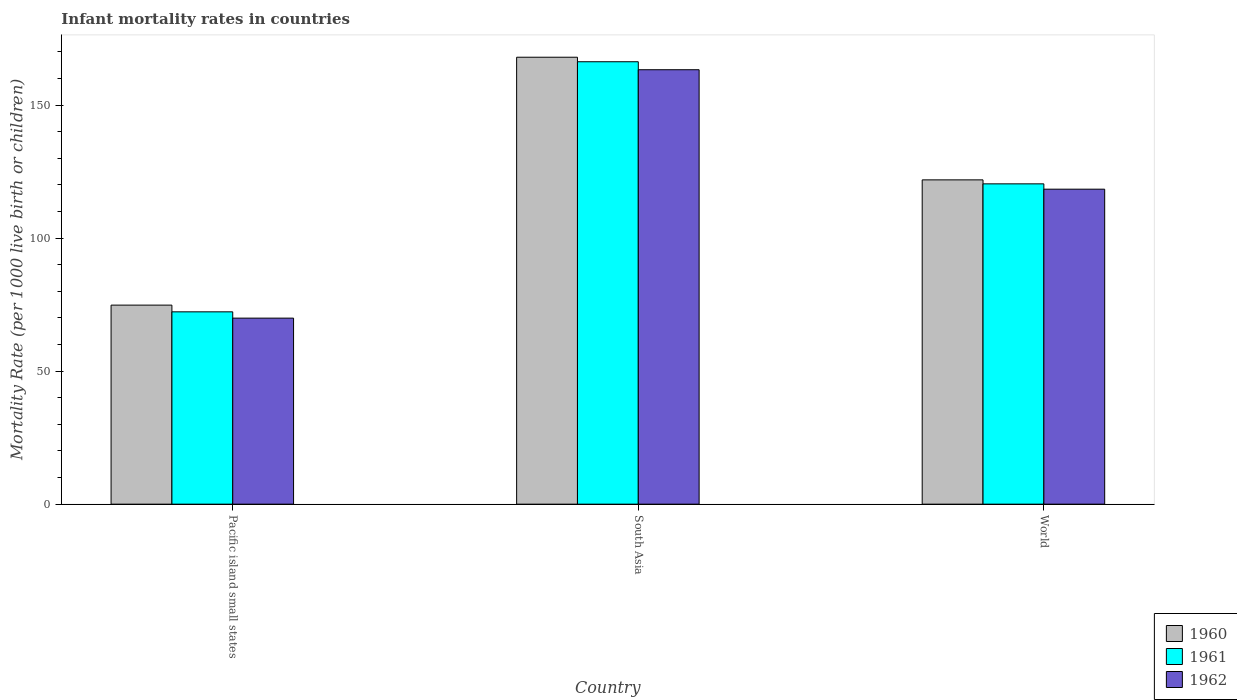Are the number of bars on each tick of the X-axis equal?
Make the answer very short. Yes. What is the label of the 2nd group of bars from the left?
Offer a very short reply. South Asia. In how many cases, is the number of bars for a given country not equal to the number of legend labels?
Your answer should be compact. 0. What is the infant mortality rate in 1961 in Pacific island small states?
Provide a short and direct response. 72.29. Across all countries, what is the maximum infant mortality rate in 1961?
Give a very brief answer. 166.3. Across all countries, what is the minimum infant mortality rate in 1961?
Offer a terse response. 72.29. In which country was the infant mortality rate in 1961 minimum?
Offer a terse response. Pacific island small states. What is the total infant mortality rate in 1961 in the graph?
Your answer should be compact. 358.99. What is the difference between the infant mortality rate in 1960 in Pacific island small states and that in World?
Provide a short and direct response. -47.08. What is the difference between the infant mortality rate in 1962 in Pacific island small states and the infant mortality rate in 1960 in South Asia?
Provide a short and direct response. -98.07. What is the average infant mortality rate in 1962 per country?
Keep it short and to the point. 117.21. What is the difference between the infant mortality rate of/in 1960 and infant mortality rate of/in 1962 in South Asia?
Offer a terse response. 4.7. What is the ratio of the infant mortality rate in 1960 in Pacific island small states to that in World?
Give a very brief answer. 0.61. What is the difference between the highest and the second highest infant mortality rate in 1961?
Your response must be concise. 48.11. What is the difference between the highest and the lowest infant mortality rate in 1962?
Offer a terse response. 93.37. In how many countries, is the infant mortality rate in 1961 greater than the average infant mortality rate in 1961 taken over all countries?
Your answer should be very brief. 2. What does the 1st bar from the left in Pacific island small states represents?
Offer a very short reply. 1960. What does the 3rd bar from the right in World represents?
Give a very brief answer. 1960. Are all the bars in the graph horizontal?
Provide a succinct answer. No. Are the values on the major ticks of Y-axis written in scientific E-notation?
Your response must be concise. No. Does the graph contain grids?
Offer a terse response. No. Where does the legend appear in the graph?
Offer a terse response. Bottom right. How many legend labels are there?
Provide a short and direct response. 3. How are the legend labels stacked?
Make the answer very short. Vertical. What is the title of the graph?
Offer a very short reply. Infant mortality rates in countries. What is the label or title of the Y-axis?
Give a very brief answer. Mortality Rate (per 1000 live birth or children). What is the Mortality Rate (per 1000 live birth or children) in 1960 in Pacific island small states?
Offer a very short reply. 74.82. What is the Mortality Rate (per 1000 live birth or children) of 1961 in Pacific island small states?
Give a very brief answer. 72.29. What is the Mortality Rate (per 1000 live birth or children) of 1962 in Pacific island small states?
Your answer should be very brief. 69.93. What is the Mortality Rate (per 1000 live birth or children) in 1960 in South Asia?
Give a very brief answer. 168. What is the Mortality Rate (per 1000 live birth or children) of 1961 in South Asia?
Offer a terse response. 166.3. What is the Mortality Rate (per 1000 live birth or children) in 1962 in South Asia?
Your response must be concise. 163.3. What is the Mortality Rate (per 1000 live birth or children) in 1960 in World?
Provide a succinct answer. 121.9. What is the Mortality Rate (per 1000 live birth or children) in 1961 in World?
Make the answer very short. 120.4. What is the Mortality Rate (per 1000 live birth or children) of 1962 in World?
Your answer should be very brief. 118.4. Across all countries, what is the maximum Mortality Rate (per 1000 live birth or children) in 1960?
Provide a succinct answer. 168. Across all countries, what is the maximum Mortality Rate (per 1000 live birth or children) of 1961?
Your answer should be compact. 166.3. Across all countries, what is the maximum Mortality Rate (per 1000 live birth or children) of 1962?
Your response must be concise. 163.3. Across all countries, what is the minimum Mortality Rate (per 1000 live birth or children) of 1960?
Make the answer very short. 74.82. Across all countries, what is the minimum Mortality Rate (per 1000 live birth or children) in 1961?
Provide a short and direct response. 72.29. Across all countries, what is the minimum Mortality Rate (per 1000 live birth or children) of 1962?
Ensure brevity in your answer.  69.93. What is the total Mortality Rate (per 1000 live birth or children) in 1960 in the graph?
Offer a terse response. 364.72. What is the total Mortality Rate (per 1000 live birth or children) of 1961 in the graph?
Offer a very short reply. 358.99. What is the total Mortality Rate (per 1000 live birth or children) in 1962 in the graph?
Provide a succinct answer. 351.63. What is the difference between the Mortality Rate (per 1000 live birth or children) in 1960 in Pacific island small states and that in South Asia?
Make the answer very short. -93.18. What is the difference between the Mortality Rate (per 1000 live birth or children) of 1961 in Pacific island small states and that in South Asia?
Keep it short and to the point. -94.01. What is the difference between the Mortality Rate (per 1000 live birth or children) in 1962 in Pacific island small states and that in South Asia?
Keep it short and to the point. -93.37. What is the difference between the Mortality Rate (per 1000 live birth or children) of 1960 in Pacific island small states and that in World?
Ensure brevity in your answer.  -47.08. What is the difference between the Mortality Rate (per 1000 live birth or children) of 1961 in Pacific island small states and that in World?
Provide a short and direct response. -48.11. What is the difference between the Mortality Rate (per 1000 live birth or children) of 1962 in Pacific island small states and that in World?
Your answer should be very brief. -48.47. What is the difference between the Mortality Rate (per 1000 live birth or children) in 1960 in South Asia and that in World?
Provide a succinct answer. 46.1. What is the difference between the Mortality Rate (per 1000 live birth or children) of 1961 in South Asia and that in World?
Offer a very short reply. 45.9. What is the difference between the Mortality Rate (per 1000 live birth or children) in 1962 in South Asia and that in World?
Provide a short and direct response. 44.9. What is the difference between the Mortality Rate (per 1000 live birth or children) in 1960 in Pacific island small states and the Mortality Rate (per 1000 live birth or children) in 1961 in South Asia?
Provide a succinct answer. -91.48. What is the difference between the Mortality Rate (per 1000 live birth or children) in 1960 in Pacific island small states and the Mortality Rate (per 1000 live birth or children) in 1962 in South Asia?
Your response must be concise. -88.48. What is the difference between the Mortality Rate (per 1000 live birth or children) in 1961 in Pacific island small states and the Mortality Rate (per 1000 live birth or children) in 1962 in South Asia?
Offer a terse response. -91.01. What is the difference between the Mortality Rate (per 1000 live birth or children) in 1960 in Pacific island small states and the Mortality Rate (per 1000 live birth or children) in 1961 in World?
Your answer should be compact. -45.58. What is the difference between the Mortality Rate (per 1000 live birth or children) in 1960 in Pacific island small states and the Mortality Rate (per 1000 live birth or children) in 1962 in World?
Provide a succinct answer. -43.58. What is the difference between the Mortality Rate (per 1000 live birth or children) of 1961 in Pacific island small states and the Mortality Rate (per 1000 live birth or children) of 1962 in World?
Provide a short and direct response. -46.11. What is the difference between the Mortality Rate (per 1000 live birth or children) of 1960 in South Asia and the Mortality Rate (per 1000 live birth or children) of 1961 in World?
Provide a succinct answer. 47.6. What is the difference between the Mortality Rate (per 1000 live birth or children) of 1960 in South Asia and the Mortality Rate (per 1000 live birth or children) of 1962 in World?
Ensure brevity in your answer.  49.6. What is the difference between the Mortality Rate (per 1000 live birth or children) of 1961 in South Asia and the Mortality Rate (per 1000 live birth or children) of 1962 in World?
Keep it short and to the point. 47.9. What is the average Mortality Rate (per 1000 live birth or children) in 1960 per country?
Offer a very short reply. 121.57. What is the average Mortality Rate (per 1000 live birth or children) of 1961 per country?
Keep it short and to the point. 119.66. What is the average Mortality Rate (per 1000 live birth or children) of 1962 per country?
Your response must be concise. 117.21. What is the difference between the Mortality Rate (per 1000 live birth or children) of 1960 and Mortality Rate (per 1000 live birth or children) of 1961 in Pacific island small states?
Offer a very short reply. 2.53. What is the difference between the Mortality Rate (per 1000 live birth or children) of 1960 and Mortality Rate (per 1000 live birth or children) of 1962 in Pacific island small states?
Offer a terse response. 4.89. What is the difference between the Mortality Rate (per 1000 live birth or children) in 1961 and Mortality Rate (per 1000 live birth or children) in 1962 in Pacific island small states?
Keep it short and to the point. 2.37. What is the difference between the Mortality Rate (per 1000 live birth or children) in 1960 and Mortality Rate (per 1000 live birth or children) in 1961 in South Asia?
Ensure brevity in your answer.  1.7. What is the difference between the Mortality Rate (per 1000 live birth or children) in 1960 and Mortality Rate (per 1000 live birth or children) in 1962 in South Asia?
Offer a very short reply. 4.7. What is the difference between the Mortality Rate (per 1000 live birth or children) in 1960 and Mortality Rate (per 1000 live birth or children) in 1961 in World?
Offer a very short reply. 1.5. What is the difference between the Mortality Rate (per 1000 live birth or children) in 1960 and Mortality Rate (per 1000 live birth or children) in 1962 in World?
Make the answer very short. 3.5. What is the ratio of the Mortality Rate (per 1000 live birth or children) in 1960 in Pacific island small states to that in South Asia?
Your answer should be compact. 0.45. What is the ratio of the Mortality Rate (per 1000 live birth or children) in 1961 in Pacific island small states to that in South Asia?
Offer a terse response. 0.43. What is the ratio of the Mortality Rate (per 1000 live birth or children) of 1962 in Pacific island small states to that in South Asia?
Provide a short and direct response. 0.43. What is the ratio of the Mortality Rate (per 1000 live birth or children) in 1960 in Pacific island small states to that in World?
Make the answer very short. 0.61. What is the ratio of the Mortality Rate (per 1000 live birth or children) in 1961 in Pacific island small states to that in World?
Offer a very short reply. 0.6. What is the ratio of the Mortality Rate (per 1000 live birth or children) in 1962 in Pacific island small states to that in World?
Make the answer very short. 0.59. What is the ratio of the Mortality Rate (per 1000 live birth or children) of 1960 in South Asia to that in World?
Keep it short and to the point. 1.38. What is the ratio of the Mortality Rate (per 1000 live birth or children) of 1961 in South Asia to that in World?
Ensure brevity in your answer.  1.38. What is the ratio of the Mortality Rate (per 1000 live birth or children) of 1962 in South Asia to that in World?
Provide a short and direct response. 1.38. What is the difference between the highest and the second highest Mortality Rate (per 1000 live birth or children) of 1960?
Offer a terse response. 46.1. What is the difference between the highest and the second highest Mortality Rate (per 1000 live birth or children) in 1961?
Provide a succinct answer. 45.9. What is the difference between the highest and the second highest Mortality Rate (per 1000 live birth or children) in 1962?
Keep it short and to the point. 44.9. What is the difference between the highest and the lowest Mortality Rate (per 1000 live birth or children) of 1960?
Keep it short and to the point. 93.18. What is the difference between the highest and the lowest Mortality Rate (per 1000 live birth or children) of 1961?
Offer a very short reply. 94.01. What is the difference between the highest and the lowest Mortality Rate (per 1000 live birth or children) in 1962?
Your answer should be compact. 93.37. 